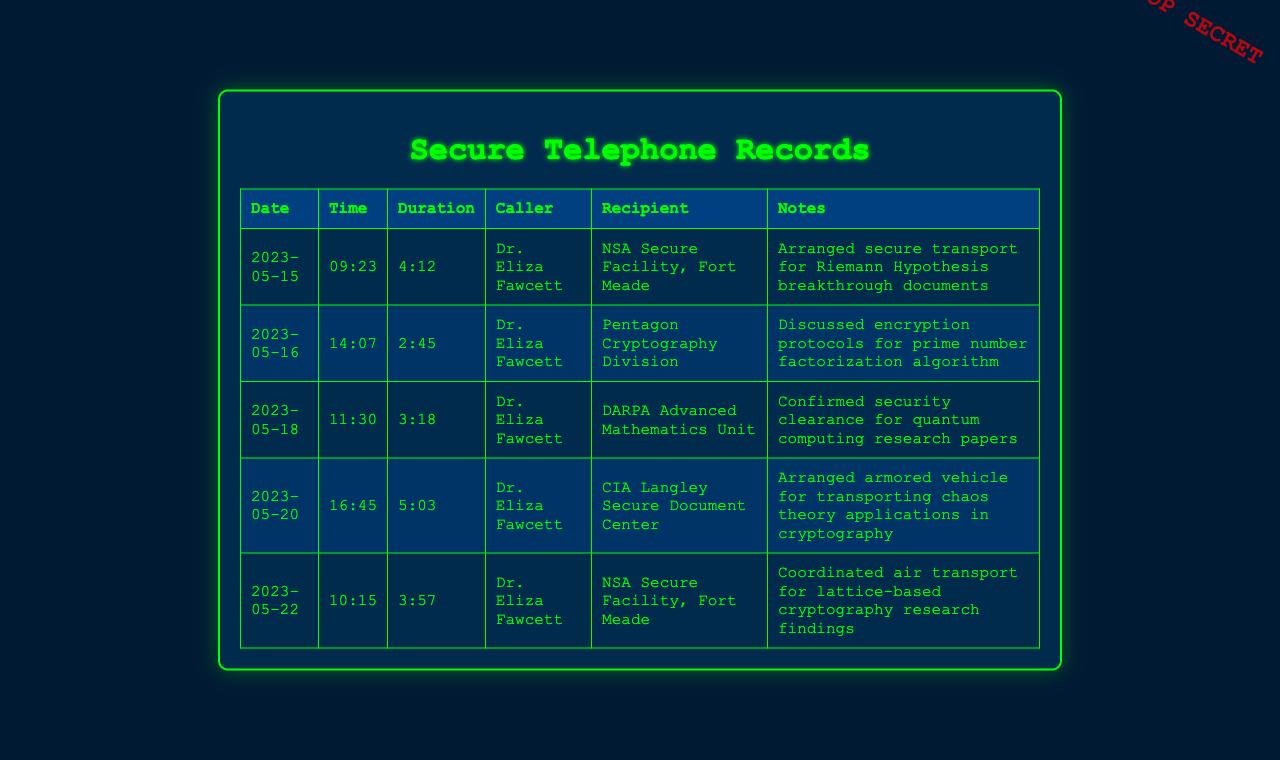What is the date of the first call? The first call in the document is listed under the date 2023-05-15.
Answer: 2023-05-15 Who was the caller in all the recorded calls? Each call lists Dr. Eliza Fawcett as the caller consistently throughout the document.
Answer: Dr. Eliza Fawcett What was discussed in the call on May 16? The notes for the call on May 16 indicate a discussion regarding encryption protocols for a specific algorithm.
Answer: Encryption protocols for prime number factorization algorithm How long was the call on May 20? The duration of the call on May 20 is recorded as 5 minutes and 3 seconds.
Answer: 5:03 Which facility was contacted to arrange armored vehicle transport? The document specifies that the CIA Langley Secure Document Center was contacted for this arrangement.
Answer: CIA Langley Secure Document Center How many calls were made to the NSA Secure Facility, Fort Meade? There are two calls recorded to the NSA Secure Facility, Fort Meade on separate dates in the document.
Answer: 2 What was the primary focus during the call on May 22? The notes indicate that the focus was on coordinating air transport for a specific type of research findings.
Answer: Lattice-based cryptography research findings What type of transport was arranged for the chaos theory applications? The document mentions that an armored vehicle was arranged for the transportation of the specified documents.
Answer: Armored vehicle 